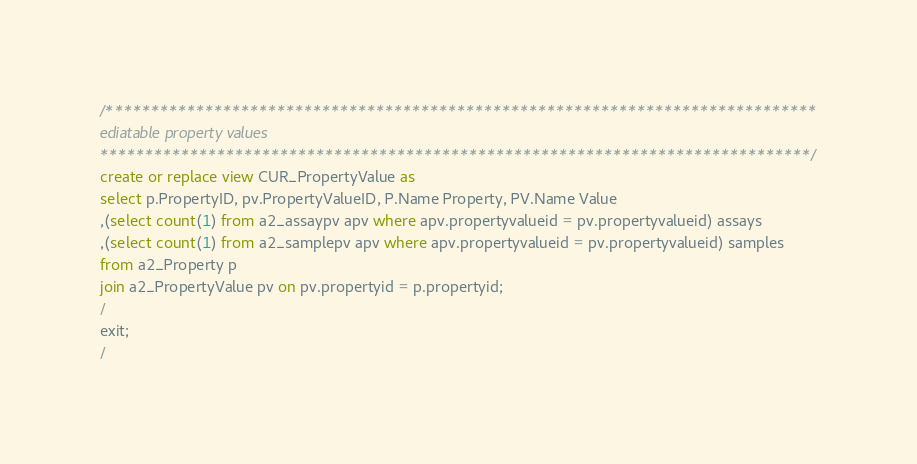<code> <loc_0><loc_0><loc_500><loc_500><_SQL_>/*******************************************************************************
ediatable property values 
*******************************************************************************/
create or replace view CUR_PropertyValue as
select p.PropertyID, pv.PropertyValueID, P.Name Property, PV.Name Value
,(select count(1) from a2_assaypv apv where apv.propertyvalueid = pv.propertyvalueid) assays
,(select count(1) from a2_samplepv apv where apv.propertyvalueid = pv.propertyvalueid) samples
from a2_Property p
join a2_PropertyValue pv on pv.propertyid = p.propertyid;
/
exit;
/</code> 